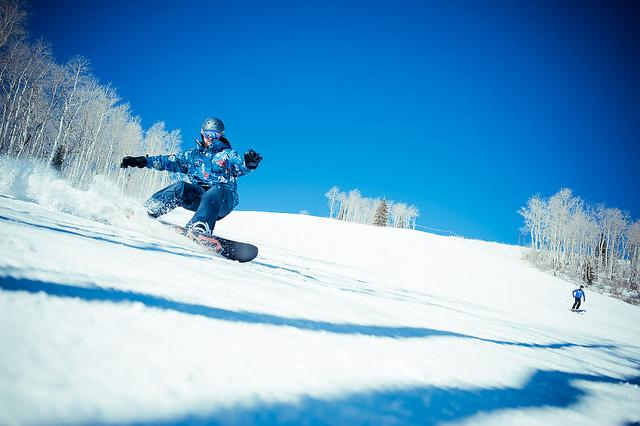In which direction is this snowboarder moving? downhill 